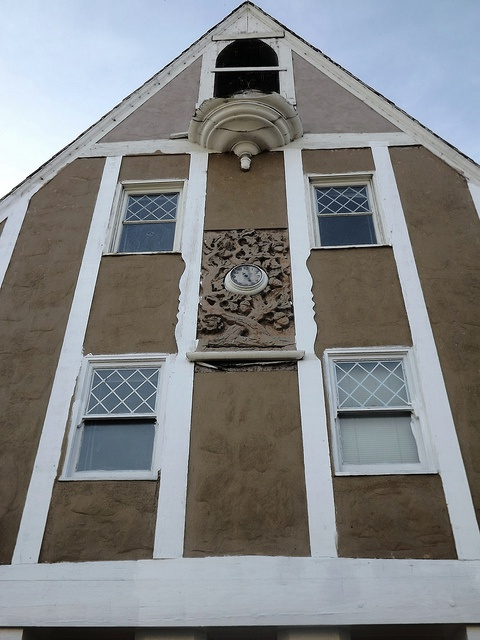Describe the objects in this image and their specific colors. I can see a clock in lavender, darkgray, gray, and black tones in this image. 